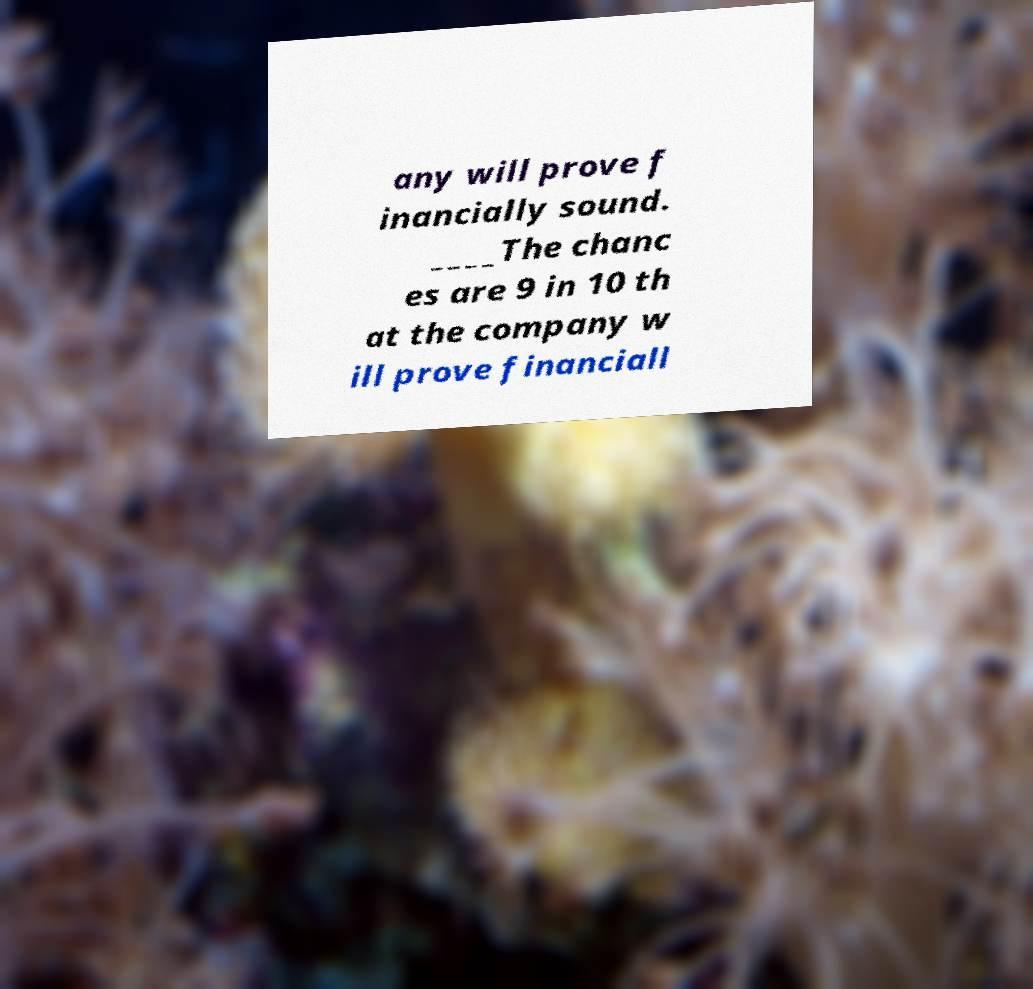There's text embedded in this image that I need extracted. Can you transcribe it verbatim? any will prove f inancially sound. ____The chanc es are 9 in 10 th at the company w ill prove financiall 